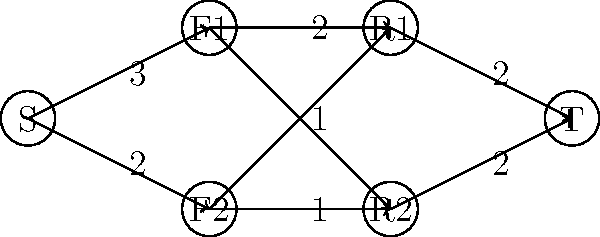In a community outreach program, you're tasked with connecting families in need (F1 and F2) with available resources (R1 and R2). The flow network above represents the situation, where S is the source and T is the sink. The numbers on the edges represent the maximum number of connections that can be made. What is the maximum number of connections that can be established between families and resources? To solve this problem, we need to find the maximum flow in the given network. We can use the Ford-Fulkerson algorithm to calculate this:

1. Start with zero flow on all edges.

2. Find an augmenting path from S to T:
   S -> F1 -> R1 -> T (Flow: 2)
   Update residual graph and add 2 to total flow.

3. Find another augmenting path:
   S -> F2 -> R2 -> T (Flow: 1)
   Update residual graph and add 1 to total flow.

4. Find another augmenting path:
   S -> F2 -> R1 -> T (Flow: 1)
   Update residual graph and add 1 to total flow.

5. No more augmenting paths exist.

The maximum flow is the sum of all augmenting path flows: 2 + 1 + 1 = 4.

This means that a total of 4 connections can be established between families and resources:
- 2 connections from F1 to R1
- 1 connection from F2 to R2
- 1 connection from F2 to R1
Answer: 4 connections 